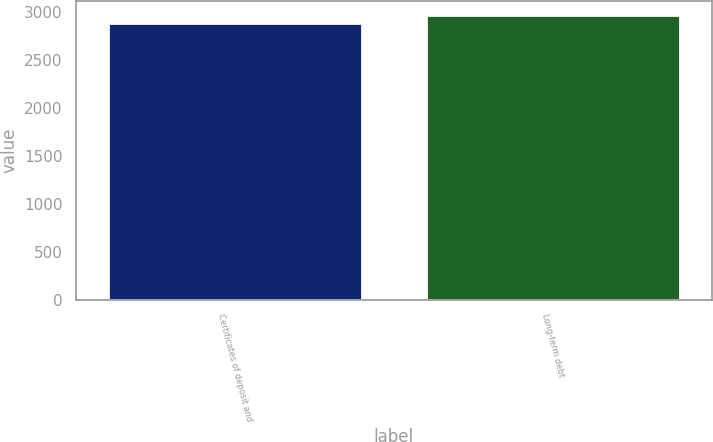Convert chart to OTSL. <chart><loc_0><loc_0><loc_500><loc_500><bar_chart><fcel>Certificates of deposit and<fcel>Long-term debt<nl><fcel>2887<fcel>2973<nl></chart> 